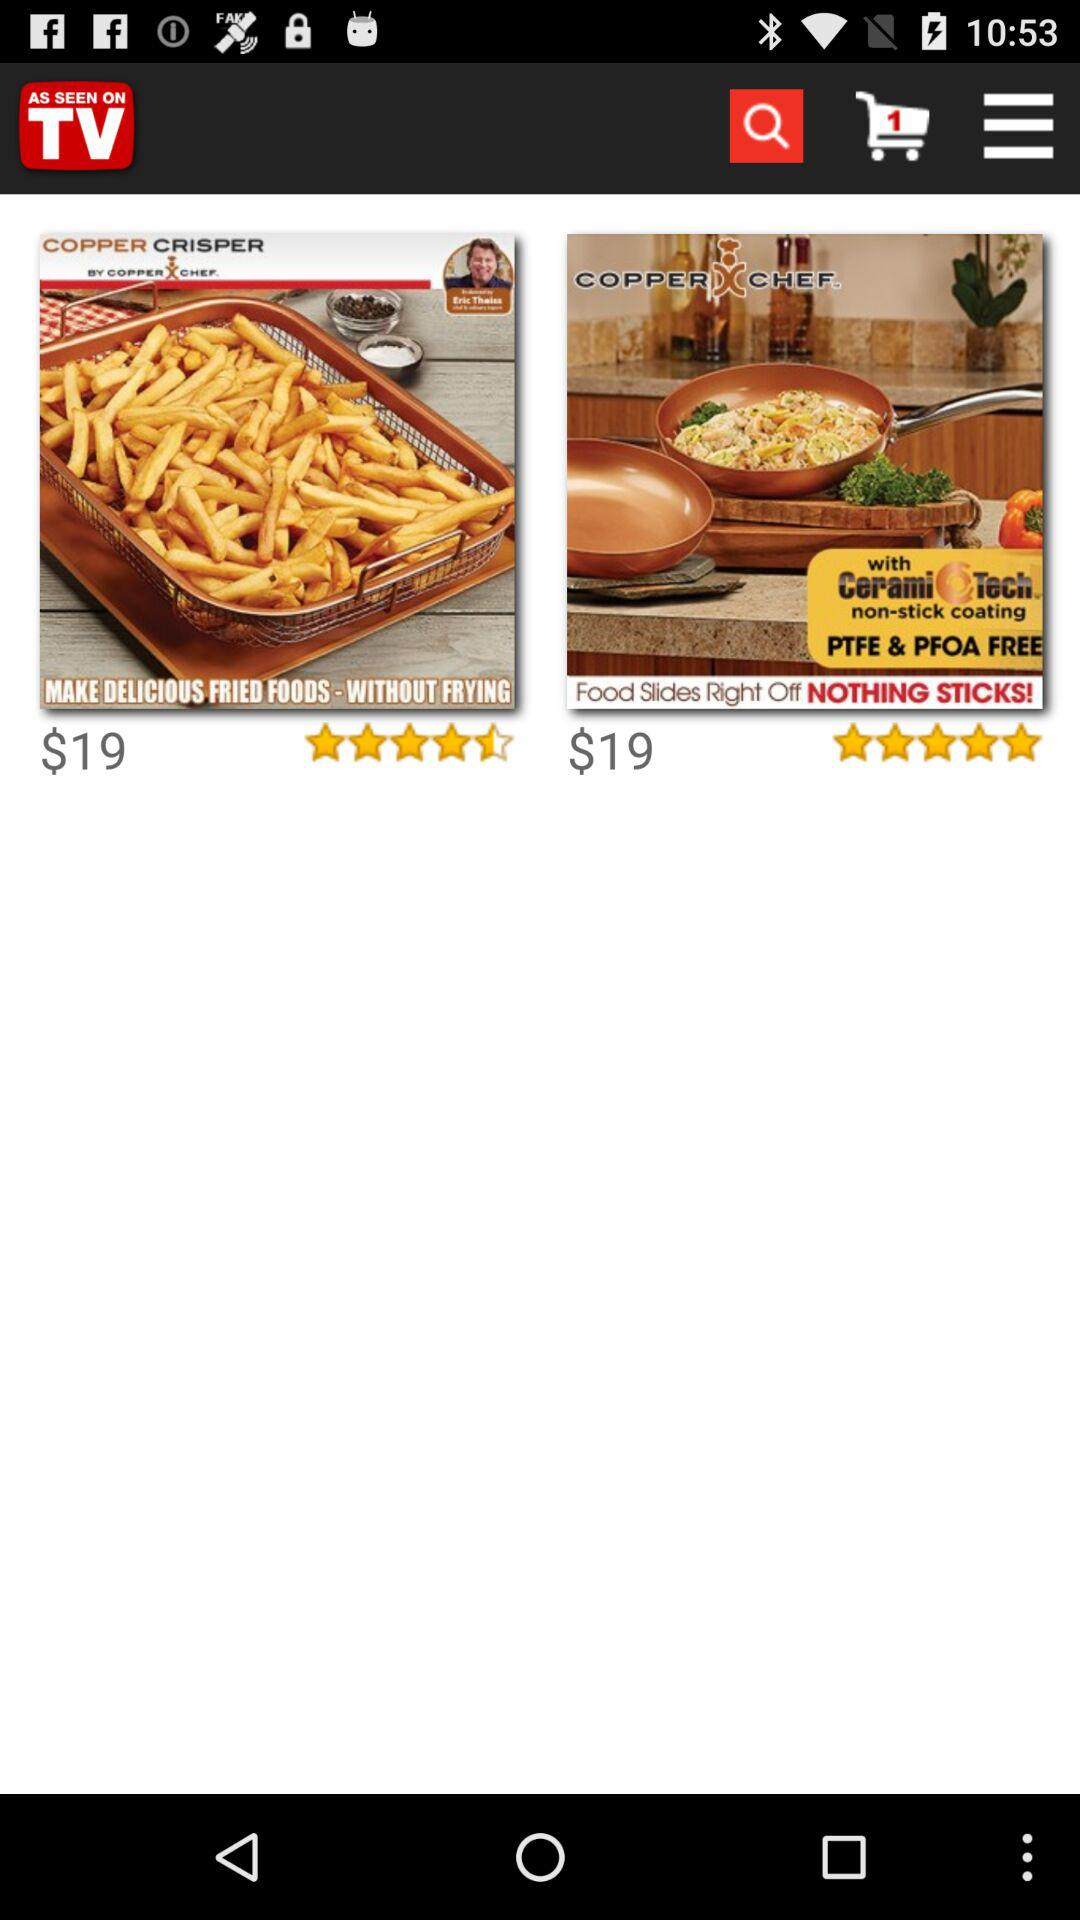What is the highest rating?
When the provided information is insufficient, respond with <no answer>. <no answer> 